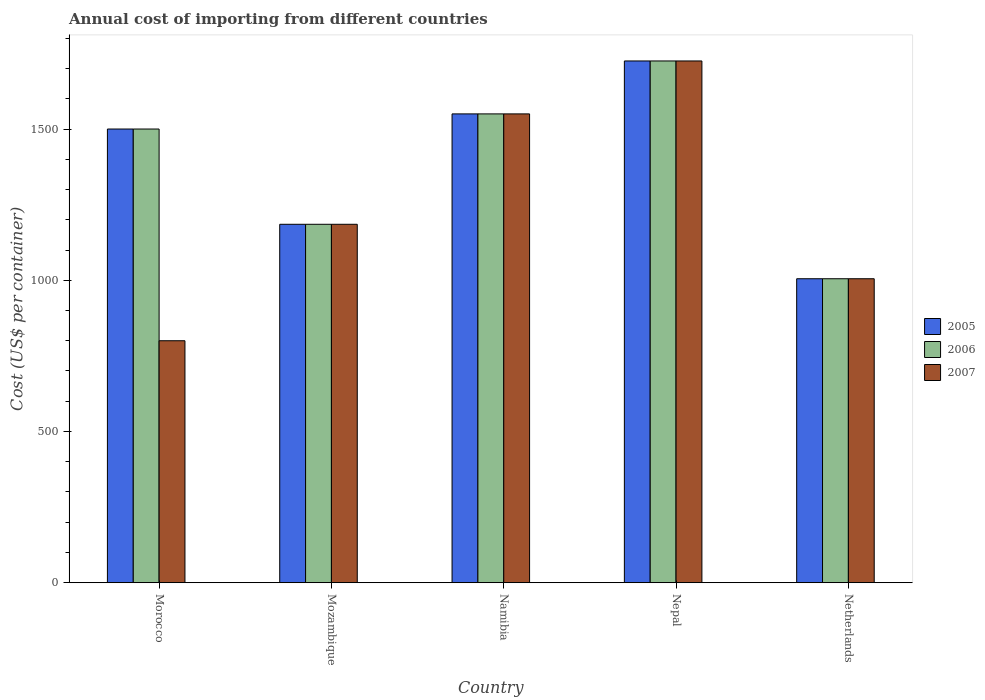How many different coloured bars are there?
Offer a very short reply. 3. Are the number of bars on each tick of the X-axis equal?
Give a very brief answer. Yes. In how many cases, is the number of bars for a given country not equal to the number of legend labels?
Offer a very short reply. 0. What is the total annual cost of importing in 2005 in Morocco?
Provide a succinct answer. 1500. Across all countries, what is the maximum total annual cost of importing in 2007?
Your answer should be very brief. 1725. Across all countries, what is the minimum total annual cost of importing in 2006?
Offer a terse response. 1005. In which country was the total annual cost of importing in 2007 maximum?
Provide a succinct answer. Nepal. In which country was the total annual cost of importing in 2006 minimum?
Ensure brevity in your answer.  Netherlands. What is the total total annual cost of importing in 2007 in the graph?
Your answer should be very brief. 6265. What is the difference between the total annual cost of importing in 2005 in Morocco and that in Namibia?
Your answer should be compact. -50. What is the difference between the total annual cost of importing in 2005 in Morocco and the total annual cost of importing in 2006 in Netherlands?
Provide a succinct answer. 495. What is the average total annual cost of importing in 2006 per country?
Ensure brevity in your answer.  1393. What is the ratio of the total annual cost of importing in 2005 in Namibia to that in Netherlands?
Offer a terse response. 1.54. Is the total annual cost of importing in 2005 in Morocco less than that in Namibia?
Offer a very short reply. Yes. Is the difference between the total annual cost of importing in 2006 in Nepal and Netherlands greater than the difference between the total annual cost of importing in 2005 in Nepal and Netherlands?
Provide a succinct answer. No. What is the difference between the highest and the second highest total annual cost of importing in 2005?
Make the answer very short. -225. What is the difference between the highest and the lowest total annual cost of importing in 2006?
Make the answer very short. 720. In how many countries, is the total annual cost of importing in 2005 greater than the average total annual cost of importing in 2005 taken over all countries?
Your response must be concise. 3. Is the sum of the total annual cost of importing in 2006 in Morocco and Nepal greater than the maximum total annual cost of importing in 2005 across all countries?
Your response must be concise. Yes. What does the 2nd bar from the right in Namibia represents?
Provide a short and direct response. 2006. How many countries are there in the graph?
Provide a succinct answer. 5. What is the difference between two consecutive major ticks on the Y-axis?
Keep it short and to the point. 500. Where does the legend appear in the graph?
Offer a very short reply. Center right. How many legend labels are there?
Ensure brevity in your answer.  3. What is the title of the graph?
Ensure brevity in your answer.  Annual cost of importing from different countries. What is the label or title of the X-axis?
Ensure brevity in your answer.  Country. What is the label or title of the Y-axis?
Offer a very short reply. Cost (US$ per container). What is the Cost (US$ per container) in 2005 in Morocco?
Provide a short and direct response. 1500. What is the Cost (US$ per container) of 2006 in Morocco?
Provide a succinct answer. 1500. What is the Cost (US$ per container) in 2007 in Morocco?
Ensure brevity in your answer.  800. What is the Cost (US$ per container) in 2005 in Mozambique?
Provide a short and direct response. 1185. What is the Cost (US$ per container) in 2006 in Mozambique?
Give a very brief answer. 1185. What is the Cost (US$ per container) of 2007 in Mozambique?
Your answer should be compact. 1185. What is the Cost (US$ per container) in 2005 in Namibia?
Provide a short and direct response. 1550. What is the Cost (US$ per container) in 2006 in Namibia?
Ensure brevity in your answer.  1550. What is the Cost (US$ per container) in 2007 in Namibia?
Offer a very short reply. 1550. What is the Cost (US$ per container) in 2005 in Nepal?
Provide a succinct answer. 1725. What is the Cost (US$ per container) of 2006 in Nepal?
Your answer should be very brief. 1725. What is the Cost (US$ per container) in 2007 in Nepal?
Offer a terse response. 1725. What is the Cost (US$ per container) in 2005 in Netherlands?
Provide a short and direct response. 1005. What is the Cost (US$ per container) of 2006 in Netherlands?
Your response must be concise. 1005. What is the Cost (US$ per container) in 2007 in Netherlands?
Ensure brevity in your answer.  1005. Across all countries, what is the maximum Cost (US$ per container) of 2005?
Keep it short and to the point. 1725. Across all countries, what is the maximum Cost (US$ per container) of 2006?
Your response must be concise. 1725. Across all countries, what is the maximum Cost (US$ per container) in 2007?
Offer a very short reply. 1725. Across all countries, what is the minimum Cost (US$ per container) in 2005?
Your answer should be compact. 1005. Across all countries, what is the minimum Cost (US$ per container) in 2006?
Your answer should be very brief. 1005. Across all countries, what is the minimum Cost (US$ per container) of 2007?
Ensure brevity in your answer.  800. What is the total Cost (US$ per container) of 2005 in the graph?
Your response must be concise. 6965. What is the total Cost (US$ per container) in 2006 in the graph?
Keep it short and to the point. 6965. What is the total Cost (US$ per container) of 2007 in the graph?
Your answer should be compact. 6265. What is the difference between the Cost (US$ per container) in 2005 in Morocco and that in Mozambique?
Your response must be concise. 315. What is the difference between the Cost (US$ per container) of 2006 in Morocco and that in Mozambique?
Give a very brief answer. 315. What is the difference between the Cost (US$ per container) in 2007 in Morocco and that in Mozambique?
Provide a short and direct response. -385. What is the difference between the Cost (US$ per container) of 2006 in Morocco and that in Namibia?
Make the answer very short. -50. What is the difference between the Cost (US$ per container) in 2007 in Morocco and that in Namibia?
Give a very brief answer. -750. What is the difference between the Cost (US$ per container) of 2005 in Morocco and that in Nepal?
Your answer should be very brief. -225. What is the difference between the Cost (US$ per container) in 2006 in Morocco and that in Nepal?
Offer a terse response. -225. What is the difference between the Cost (US$ per container) in 2007 in Morocco and that in Nepal?
Make the answer very short. -925. What is the difference between the Cost (US$ per container) in 2005 in Morocco and that in Netherlands?
Your answer should be very brief. 495. What is the difference between the Cost (US$ per container) of 2006 in Morocco and that in Netherlands?
Provide a short and direct response. 495. What is the difference between the Cost (US$ per container) of 2007 in Morocco and that in Netherlands?
Offer a very short reply. -205. What is the difference between the Cost (US$ per container) in 2005 in Mozambique and that in Namibia?
Offer a very short reply. -365. What is the difference between the Cost (US$ per container) in 2006 in Mozambique and that in Namibia?
Provide a succinct answer. -365. What is the difference between the Cost (US$ per container) of 2007 in Mozambique and that in Namibia?
Offer a very short reply. -365. What is the difference between the Cost (US$ per container) of 2005 in Mozambique and that in Nepal?
Your answer should be compact. -540. What is the difference between the Cost (US$ per container) of 2006 in Mozambique and that in Nepal?
Provide a short and direct response. -540. What is the difference between the Cost (US$ per container) in 2007 in Mozambique and that in Nepal?
Make the answer very short. -540. What is the difference between the Cost (US$ per container) in 2005 in Mozambique and that in Netherlands?
Make the answer very short. 180. What is the difference between the Cost (US$ per container) in 2006 in Mozambique and that in Netherlands?
Ensure brevity in your answer.  180. What is the difference between the Cost (US$ per container) in 2007 in Mozambique and that in Netherlands?
Give a very brief answer. 180. What is the difference between the Cost (US$ per container) of 2005 in Namibia and that in Nepal?
Offer a terse response. -175. What is the difference between the Cost (US$ per container) of 2006 in Namibia and that in Nepal?
Make the answer very short. -175. What is the difference between the Cost (US$ per container) of 2007 in Namibia and that in Nepal?
Make the answer very short. -175. What is the difference between the Cost (US$ per container) in 2005 in Namibia and that in Netherlands?
Give a very brief answer. 545. What is the difference between the Cost (US$ per container) in 2006 in Namibia and that in Netherlands?
Your answer should be very brief. 545. What is the difference between the Cost (US$ per container) in 2007 in Namibia and that in Netherlands?
Ensure brevity in your answer.  545. What is the difference between the Cost (US$ per container) of 2005 in Nepal and that in Netherlands?
Ensure brevity in your answer.  720. What is the difference between the Cost (US$ per container) of 2006 in Nepal and that in Netherlands?
Give a very brief answer. 720. What is the difference between the Cost (US$ per container) of 2007 in Nepal and that in Netherlands?
Provide a succinct answer. 720. What is the difference between the Cost (US$ per container) of 2005 in Morocco and the Cost (US$ per container) of 2006 in Mozambique?
Your answer should be very brief. 315. What is the difference between the Cost (US$ per container) of 2005 in Morocco and the Cost (US$ per container) of 2007 in Mozambique?
Ensure brevity in your answer.  315. What is the difference between the Cost (US$ per container) in 2006 in Morocco and the Cost (US$ per container) in 2007 in Mozambique?
Your answer should be very brief. 315. What is the difference between the Cost (US$ per container) in 2006 in Morocco and the Cost (US$ per container) in 2007 in Namibia?
Provide a short and direct response. -50. What is the difference between the Cost (US$ per container) in 2005 in Morocco and the Cost (US$ per container) in 2006 in Nepal?
Offer a very short reply. -225. What is the difference between the Cost (US$ per container) in 2005 in Morocco and the Cost (US$ per container) in 2007 in Nepal?
Make the answer very short. -225. What is the difference between the Cost (US$ per container) of 2006 in Morocco and the Cost (US$ per container) of 2007 in Nepal?
Your answer should be very brief. -225. What is the difference between the Cost (US$ per container) in 2005 in Morocco and the Cost (US$ per container) in 2006 in Netherlands?
Provide a succinct answer. 495. What is the difference between the Cost (US$ per container) in 2005 in Morocco and the Cost (US$ per container) in 2007 in Netherlands?
Offer a very short reply. 495. What is the difference between the Cost (US$ per container) in 2006 in Morocco and the Cost (US$ per container) in 2007 in Netherlands?
Make the answer very short. 495. What is the difference between the Cost (US$ per container) of 2005 in Mozambique and the Cost (US$ per container) of 2006 in Namibia?
Provide a short and direct response. -365. What is the difference between the Cost (US$ per container) of 2005 in Mozambique and the Cost (US$ per container) of 2007 in Namibia?
Your answer should be very brief. -365. What is the difference between the Cost (US$ per container) of 2006 in Mozambique and the Cost (US$ per container) of 2007 in Namibia?
Ensure brevity in your answer.  -365. What is the difference between the Cost (US$ per container) in 2005 in Mozambique and the Cost (US$ per container) in 2006 in Nepal?
Offer a very short reply. -540. What is the difference between the Cost (US$ per container) in 2005 in Mozambique and the Cost (US$ per container) in 2007 in Nepal?
Ensure brevity in your answer.  -540. What is the difference between the Cost (US$ per container) in 2006 in Mozambique and the Cost (US$ per container) in 2007 in Nepal?
Your answer should be compact. -540. What is the difference between the Cost (US$ per container) of 2005 in Mozambique and the Cost (US$ per container) of 2006 in Netherlands?
Make the answer very short. 180. What is the difference between the Cost (US$ per container) in 2005 in Mozambique and the Cost (US$ per container) in 2007 in Netherlands?
Offer a very short reply. 180. What is the difference between the Cost (US$ per container) in 2006 in Mozambique and the Cost (US$ per container) in 2007 in Netherlands?
Give a very brief answer. 180. What is the difference between the Cost (US$ per container) of 2005 in Namibia and the Cost (US$ per container) of 2006 in Nepal?
Ensure brevity in your answer.  -175. What is the difference between the Cost (US$ per container) in 2005 in Namibia and the Cost (US$ per container) in 2007 in Nepal?
Make the answer very short. -175. What is the difference between the Cost (US$ per container) in 2006 in Namibia and the Cost (US$ per container) in 2007 in Nepal?
Provide a short and direct response. -175. What is the difference between the Cost (US$ per container) in 2005 in Namibia and the Cost (US$ per container) in 2006 in Netherlands?
Provide a short and direct response. 545. What is the difference between the Cost (US$ per container) in 2005 in Namibia and the Cost (US$ per container) in 2007 in Netherlands?
Offer a very short reply. 545. What is the difference between the Cost (US$ per container) in 2006 in Namibia and the Cost (US$ per container) in 2007 in Netherlands?
Ensure brevity in your answer.  545. What is the difference between the Cost (US$ per container) in 2005 in Nepal and the Cost (US$ per container) in 2006 in Netherlands?
Your answer should be very brief. 720. What is the difference between the Cost (US$ per container) in 2005 in Nepal and the Cost (US$ per container) in 2007 in Netherlands?
Give a very brief answer. 720. What is the difference between the Cost (US$ per container) of 2006 in Nepal and the Cost (US$ per container) of 2007 in Netherlands?
Give a very brief answer. 720. What is the average Cost (US$ per container) of 2005 per country?
Keep it short and to the point. 1393. What is the average Cost (US$ per container) in 2006 per country?
Give a very brief answer. 1393. What is the average Cost (US$ per container) in 2007 per country?
Offer a very short reply. 1253. What is the difference between the Cost (US$ per container) in 2005 and Cost (US$ per container) in 2007 in Morocco?
Your response must be concise. 700. What is the difference between the Cost (US$ per container) of 2006 and Cost (US$ per container) of 2007 in Morocco?
Your answer should be very brief. 700. What is the difference between the Cost (US$ per container) of 2005 and Cost (US$ per container) of 2007 in Mozambique?
Ensure brevity in your answer.  0. What is the difference between the Cost (US$ per container) of 2005 and Cost (US$ per container) of 2006 in Namibia?
Offer a terse response. 0. What is the difference between the Cost (US$ per container) in 2005 and Cost (US$ per container) in 2007 in Nepal?
Offer a very short reply. 0. What is the difference between the Cost (US$ per container) of 2006 and Cost (US$ per container) of 2007 in Nepal?
Give a very brief answer. 0. What is the difference between the Cost (US$ per container) in 2005 and Cost (US$ per container) in 2006 in Netherlands?
Your answer should be very brief. 0. What is the difference between the Cost (US$ per container) of 2005 and Cost (US$ per container) of 2007 in Netherlands?
Your response must be concise. 0. What is the difference between the Cost (US$ per container) of 2006 and Cost (US$ per container) of 2007 in Netherlands?
Give a very brief answer. 0. What is the ratio of the Cost (US$ per container) in 2005 in Morocco to that in Mozambique?
Your answer should be very brief. 1.27. What is the ratio of the Cost (US$ per container) in 2006 in Morocco to that in Mozambique?
Make the answer very short. 1.27. What is the ratio of the Cost (US$ per container) in 2007 in Morocco to that in Mozambique?
Your answer should be very brief. 0.68. What is the ratio of the Cost (US$ per container) in 2005 in Morocco to that in Namibia?
Your response must be concise. 0.97. What is the ratio of the Cost (US$ per container) in 2006 in Morocco to that in Namibia?
Your response must be concise. 0.97. What is the ratio of the Cost (US$ per container) in 2007 in Morocco to that in Namibia?
Offer a very short reply. 0.52. What is the ratio of the Cost (US$ per container) of 2005 in Morocco to that in Nepal?
Offer a very short reply. 0.87. What is the ratio of the Cost (US$ per container) of 2006 in Morocco to that in Nepal?
Your answer should be very brief. 0.87. What is the ratio of the Cost (US$ per container) in 2007 in Morocco to that in Nepal?
Your answer should be compact. 0.46. What is the ratio of the Cost (US$ per container) in 2005 in Morocco to that in Netherlands?
Ensure brevity in your answer.  1.49. What is the ratio of the Cost (US$ per container) in 2006 in Morocco to that in Netherlands?
Provide a short and direct response. 1.49. What is the ratio of the Cost (US$ per container) of 2007 in Morocco to that in Netherlands?
Make the answer very short. 0.8. What is the ratio of the Cost (US$ per container) of 2005 in Mozambique to that in Namibia?
Your response must be concise. 0.76. What is the ratio of the Cost (US$ per container) in 2006 in Mozambique to that in Namibia?
Make the answer very short. 0.76. What is the ratio of the Cost (US$ per container) of 2007 in Mozambique to that in Namibia?
Your answer should be compact. 0.76. What is the ratio of the Cost (US$ per container) in 2005 in Mozambique to that in Nepal?
Provide a succinct answer. 0.69. What is the ratio of the Cost (US$ per container) of 2006 in Mozambique to that in Nepal?
Make the answer very short. 0.69. What is the ratio of the Cost (US$ per container) in 2007 in Mozambique to that in Nepal?
Give a very brief answer. 0.69. What is the ratio of the Cost (US$ per container) of 2005 in Mozambique to that in Netherlands?
Provide a succinct answer. 1.18. What is the ratio of the Cost (US$ per container) of 2006 in Mozambique to that in Netherlands?
Give a very brief answer. 1.18. What is the ratio of the Cost (US$ per container) of 2007 in Mozambique to that in Netherlands?
Your answer should be very brief. 1.18. What is the ratio of the Cost (US$ per container) of 2005 in Namibia to that in Nepal?
Give a very brief answer. 0.9. What is the ratio of the Cost (US$ per container) of 2006 in Namibia to that in Nepal?
Make the answer very short. 0.9. What is the ratio of the Cost (US$ per container) of 2007 in Namibia to that in Nepal?
Provide a short and direct response. 0.9. What is the ratio of the Cost (US$ per container) in 2005 in Namibia to that in Netherlands?
Make the answer very short. 1.54. What is the ratio of the Cost (US$ per container) of 2006 in Namibia to that in Netherlands?
Your answer should be very brief. 1.54. What is the ratio of the Cost (US$ per container) of 2007 in Namibia to that in Netherlands?
Ensure brevity in your answer.  1.54. What is the ratio of the Cost (US$ per container) in 2005 in Nepal to that in Netherlands?
Your answer should be very brief. 1.72. What is the ratio of the Cost (US$ per container) of 2006 in Nepal to that in Netherlands?
Provide a short and direct response. 1.72. What is the ratio of the Cost (US$ per container) of 2007 in Nepal to that in Netherlands?
Ensure brevity in your answer.  1.72. What is the difference between the highest and the second highest Cost (US$ per container) of 2005?
Your response must be concise. 175. What is the difference between the highest and the second highest Cost (US$ per container) in 2006?
Your answer should be very brief. 175. What is the difference between the highest and the second highest Cost (US$ per container) in 2007?
Make the answer very short. 175. What is the difference between the highest and the lowest Cost (US$ per container) of 2005?
Your response must be concise. 720. What is the difference between the highest and the lowest Cost (US$ per container) of 2006?
Make the answer very short. 720. What is the difference between the highest and the lowest Cost (US$ per container) in 2007?
Ensure brevity in your answer.  925. 